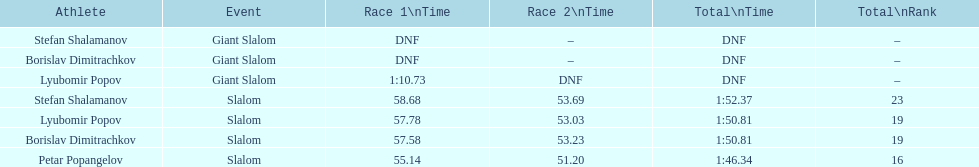What is the time difference between petar popangelov's performances in race 1 and race 2? 3.94. Parse the full table. {'header': ['Athlete', 'Event', 'Race 1\\nTime', 'Race 2\\nTime', 'Total\\nTime', 'Total\\nRank'], 'rows': [['Stefan Shalamanov', 'Giant Slalom', 'DNF', '–', 'DNF', '–'], ['Borislav Dimitrachkov', 'Giant Slalom', 'DNF', '–', 'DNF', '–'], ['Lyubomir Popov', 'Giant Slalom', '1:10.73', 'DNF', 'DNF', '–'], ['Stefan Shalamanov', 'Slalom', '58.68', '53.69', '1:52.37', '23'], ['Lyubomir Popov', 'Slalom', '57.78', '53.03', '1:50.81', '19'], ['Borislav Dimitrachkov', 'Slalom', '57.58', '53.23', '1:50.81', '19'], ['Petar Popangelov', 'Slalom', '55.14', '51.20', '1:46.34', '16']]} 